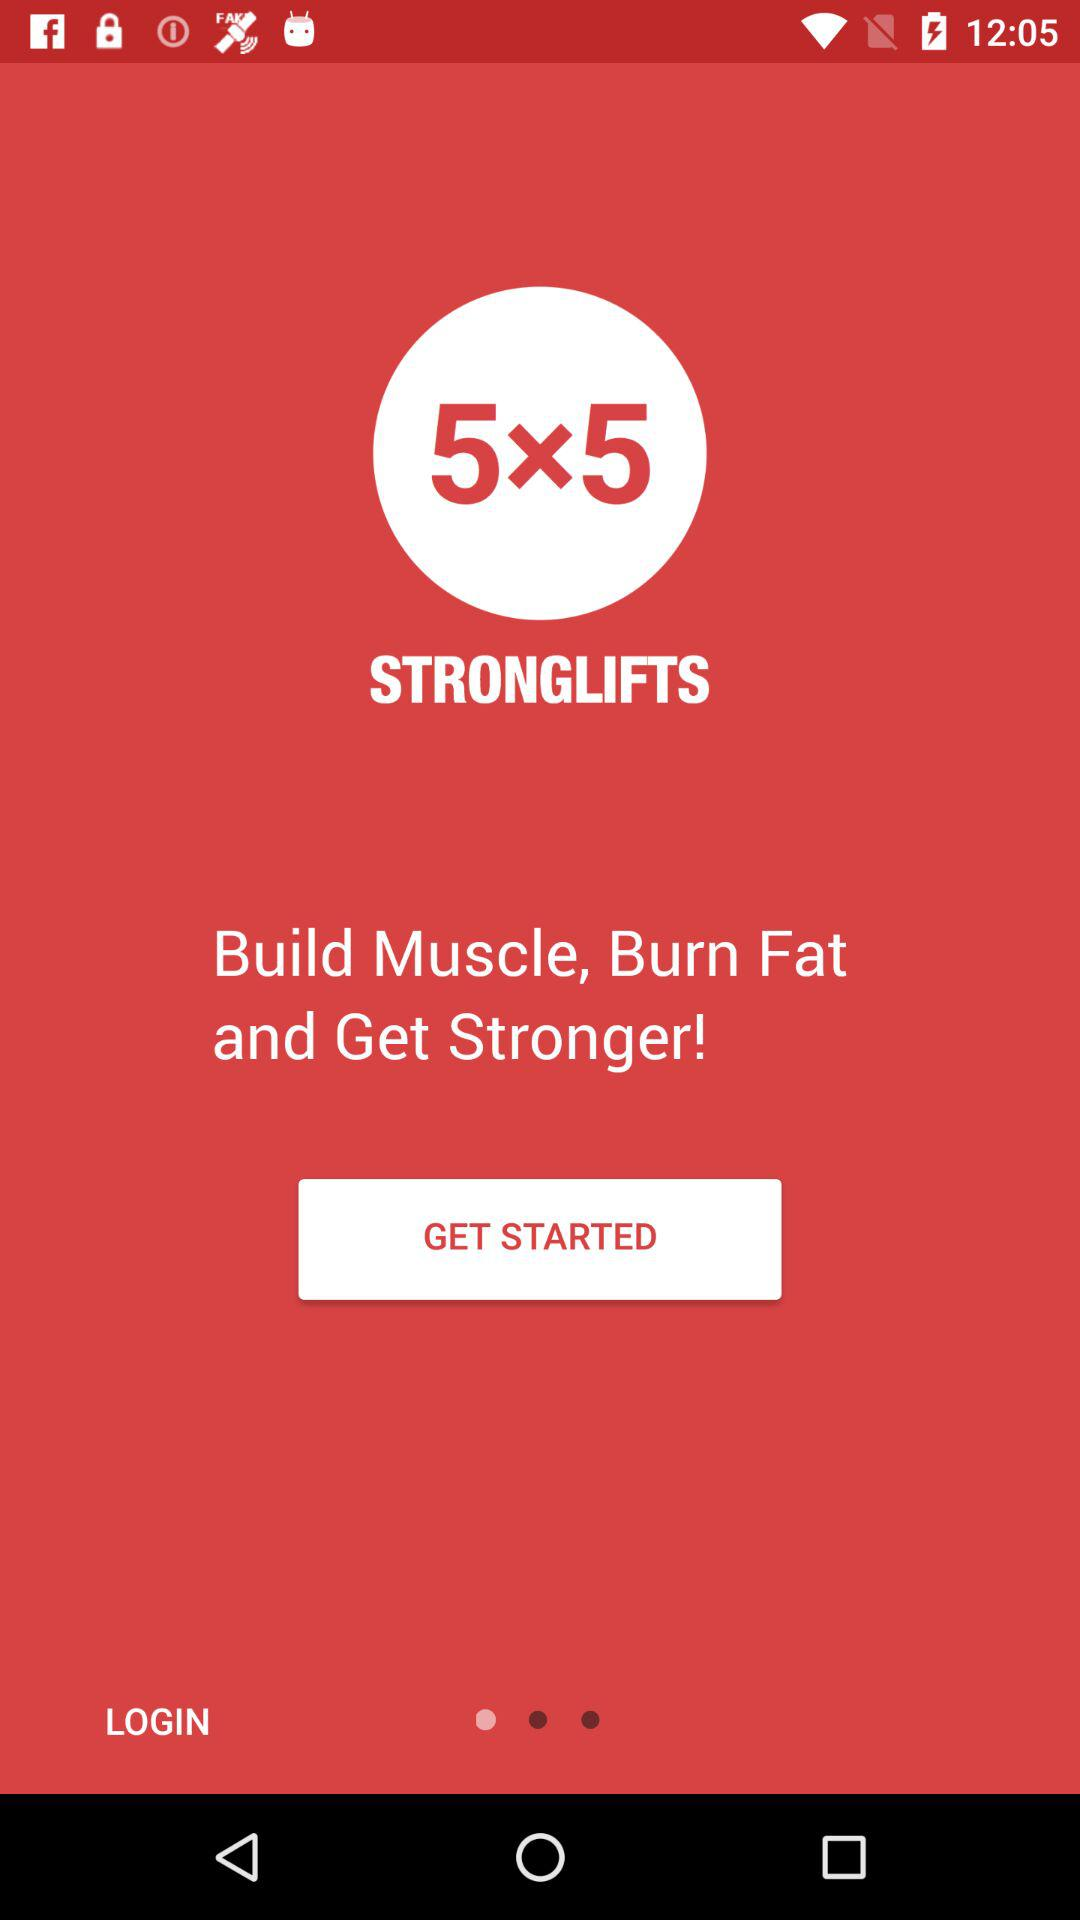What is the application name? The application name is "Stronglifts 5x5". 